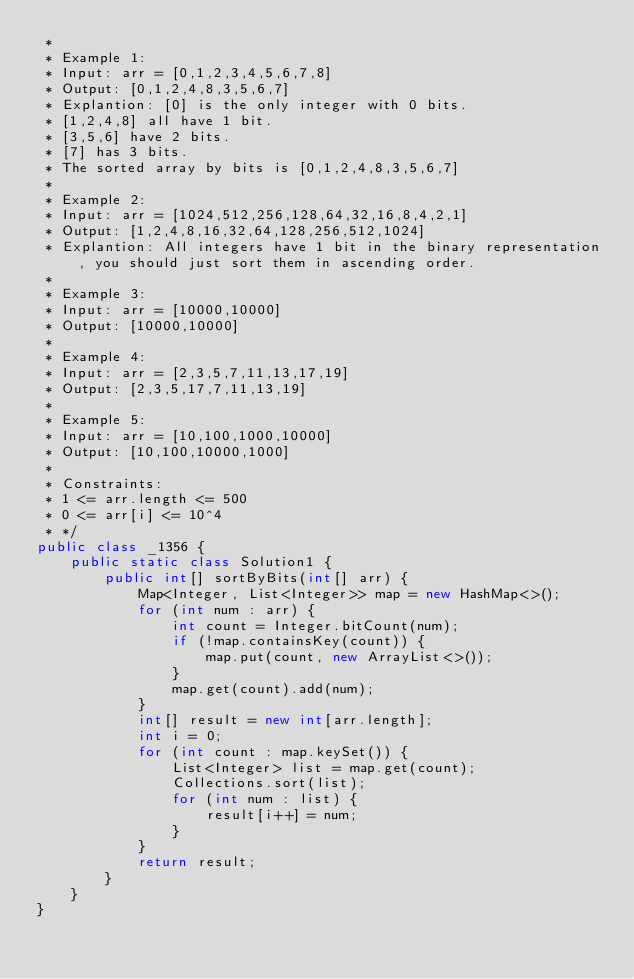<code> <loc_0><loc_0><loc_500><loc_500><_Java_> *
 * Example 1:
 * Input: arr = [0,1,2,3,4,5,6,7,8]
 * Output: [0,1,2,4,8,3,5,6,7]
 * Explantion: [0] is the only integer with 0 bits.
 * [1,2,4,8] all have 1 bit.
 * [3,5,6] have 2 bits.
 * [7] has 3 bits.
 * The sorted array by bits is [0,1,2,4,8,3,5,6,7]
 *
 * Example 2:
 * Input: arr = [1024,512,256,128,64,32,16,8,4,2,1]
 * Output: [1,2,4,8,16,32,64,128,256,512,1024]
 * Explantion: All integers have 1 bit in the binary representation, you should just sort them in ascending order.
 *
 * Example 3:
 * Input: arr = [10000,10000]
 * Output: [10000,10000]
 *
 * Example 4:
 * Input: arr = [2,3,5,7,11,13,17,19]
 * Output: [2,3,5,17,7,11,13,19]
 *
 * Example 5:
 * Input: arr = [10,100,1000,10000]
 * Output: [10,100,10000,1000]
 *
 * Constraints:
 * 1 <= arr.length <= 500
 * 0 <= arr[i] <= 10^4
 * */
public class _1356 {
    public static class Solution1 {
        public int[] sortByBits(int[] arr) {
            Map<Integer, List<Integer>> map = new HashMap<>();
            for (int num : arr) {
                int count = Integer.bitCount(num);
                if (!map.containsKey(count)) {
                    map.put(count, new ArrayList<>());
                }
                map.get(count).add(num);
            }
            int[] result = new int[arr.length];
            int i = 0;
            for (int count : map.keySet()) {
                List<Integer> list = map.get(count);
                Collections.sort(list);
                for (int num : list) {
                    result[i++] = num;
                }
            }
            return result;
        }
    }
}
</code> 